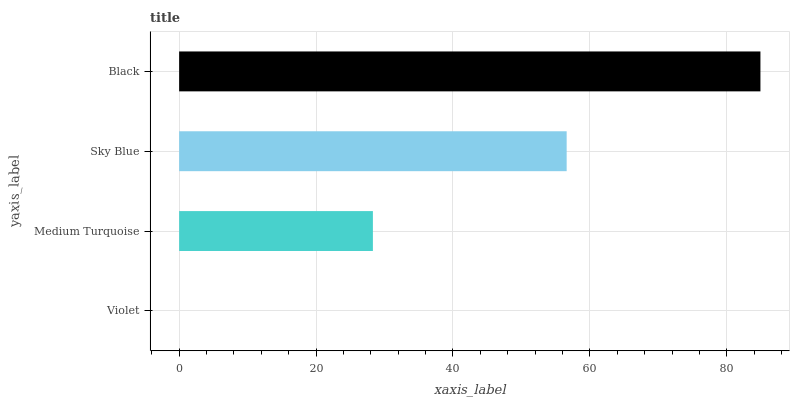Is Violet the minimum?
Answer yes or no. Yes. Is Black the maximum?
Answer yes or no. Yes. Is Medium Turquoise the minimum?
Answer yes or no. No. Is Medium Turquoise the maximum?
Answer yes or no. No. Is Medium Turquoise greater than Violet?
Answer yes or no. Yes. Is Violet less than Medium Turquoise?
Answer yes or no. Yes. Is Violet greater than Medium Turquoise?
Answer yes or no. No. Is Medium Turquoise less than Violet?
Answer yes or no. No. Is Sky Blue the high median?
Answer yes or no. Yes. Is Medium Turquoise the low median?
Answer yes or no. Yes. Is Violet the high median?
Answer yes or no. No. Is Sky Blue the low median?
Answer yes or no. No. 